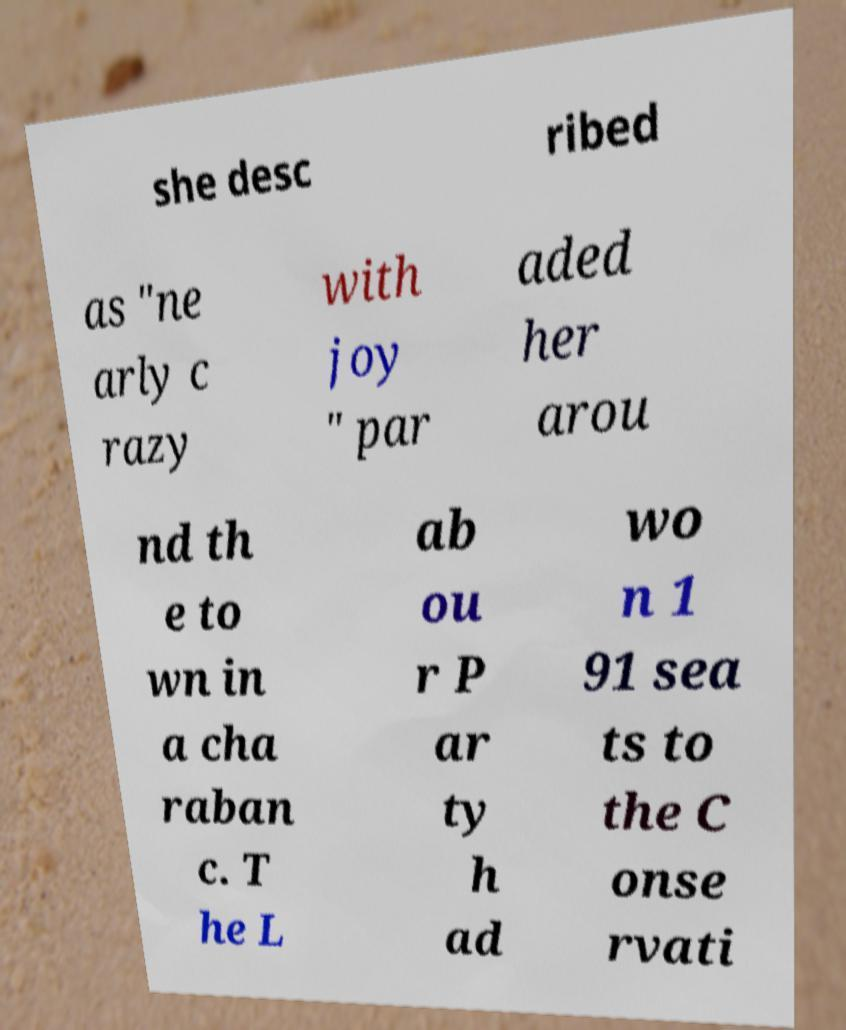I need the written content from this picture converted into text. Can you do that? she desc ribed as "ne arly c razy with joy " par aded her arou nd th e to wn in a cha raban c. T he L ab ou r P ar ty h ad wo n 1 91 sea ts to the C onse rvati 